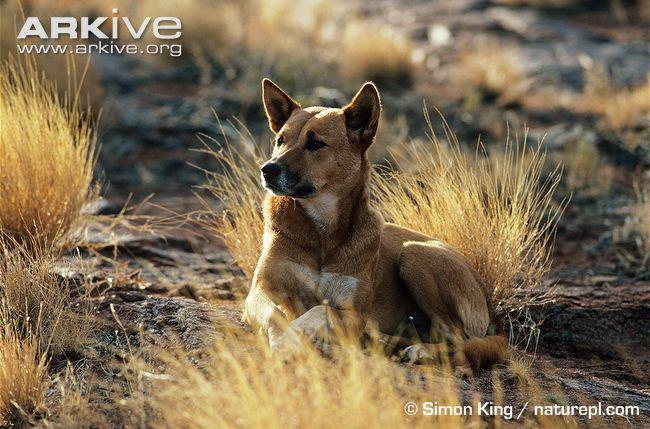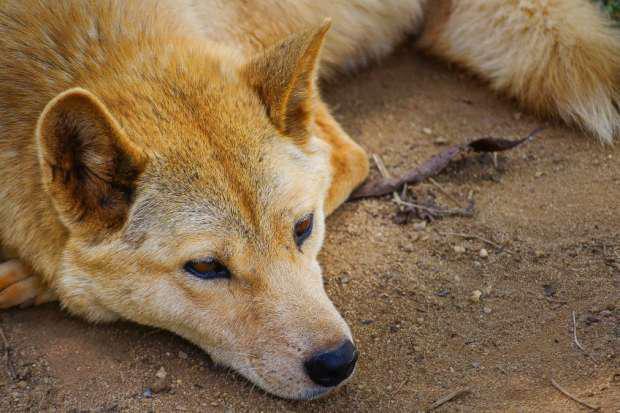The first image is the image on the left, the second image is the image on the right. Given the left and right images, does the statement "there is a canine lying down in the image to the left" hold true? Answer yes or no. Yes. The first image is the image on the left, the second image is the image on the right. Assess this claim about the two images: "The left image features a dingo reclining with upright head, and all dingos shown are adults.". Correct or not? Answer yes or no. Yes. 